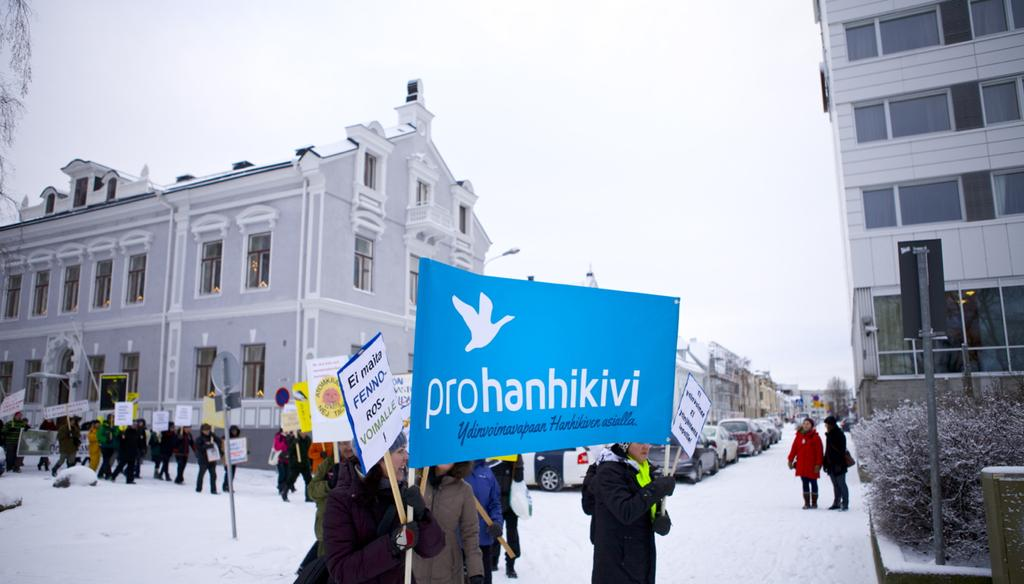<image>
Create a compact narrative representing the image presented. Several people holding a sign that says prohanhikivi 